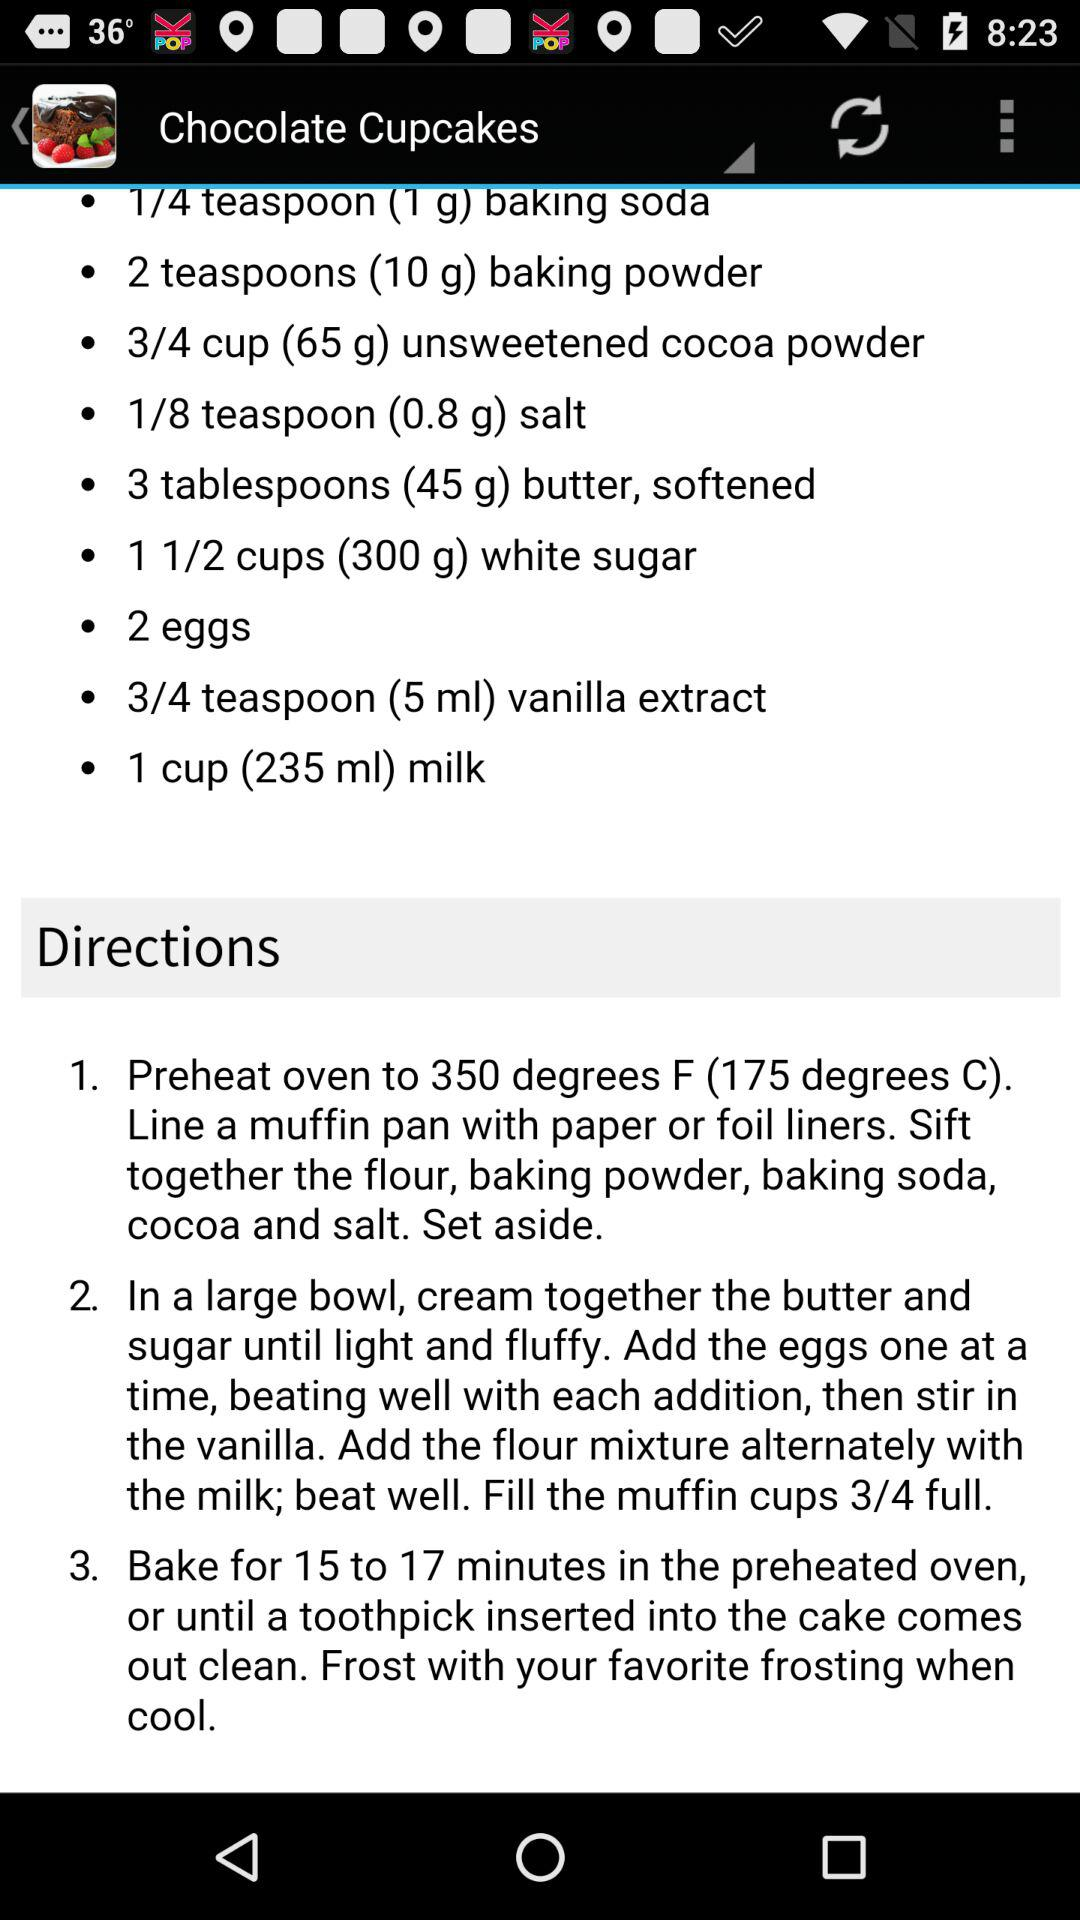What is the given amount of white sugar for the chocolate cupcake? The given amount of white sugar is one and a half cup (300 g). 